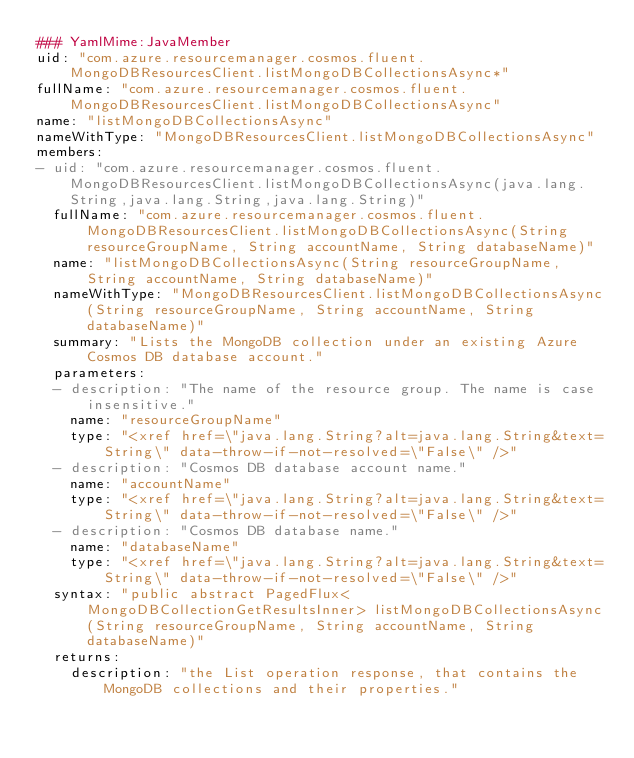Convert code to text. <code><loc_0><loc_0><loc_500><loc_500><_YAML_>### YamlMime:JavaMember
uid: "com.azure.resourcemanager.cosmos.fluent.MongoDBResourcesClient.listMongoDBCollectionsAsync*"
fullName: "com.azure.resourcemanager.cosmos.fluent.MongoDBResourcesClient.listMongoDBCollectionsAsync"
name: "listMongoDBCollectionsAsync"
nameWithType: "MongoDBResourcesClient.listMongoDBCollectionsAsync"
members:
- uid: "com.azure.resourcemanager.cosmos.fluent.MongoDBResourcesClient.listMongoDBCollectionsAsync(java.lang.String,java.lang.String,java.lang.String)"
  fullName: "com.azure.resourcemanager.cosmos.fluent.MongoDBResourcesClient.listMongoDBCollectionsAsync(String resourceGroupName, String accountName, String databaseName)"
  name: "listMongoDBCollectionsAsync(String resourceGroupName, String accountName, String databaseName)"
  nameWithType: "MongoDBResourcesClient.listMongoDBCollectionsAsync(String resourceGroupName, String accountName, String databaseName)"
  summary: "Lists the MongoDB collection under an existing Azure Cosmos DB database account."
  parameters:
  - description: "The name of the resource group. The name is case insensitive."
    name: "resourceGroupName"
    type: "<xref href=\"java.lang.String?alt=java.lang.String&text=String\" data-throw-if-not-resolved=\"False\" />"
  - description: "Cosmos DB database account name."
    name: "accountName"
    type: "<xref href=\"java.lang.String?alt=java.lang.String&text=String\" data-throw-if-not-resolved=\"False\" />"
  - description: "Cosmos DB database name."
    name: "databaseName"
    type: "<xref href=\"java.lang.String?alt=java.lang.String&text=String\" data-throw-if-not-resolved=\"False\" />"
  syntax: "public abstract PagedFlux<MongoDBCollectionGetResultsInner> listMongoDBCollectionsAsync(String resourceGroupName, String accountName, String databaseName)"
  returns:
    description: "the List operation response, that contains the MongoDB collections and their properties."</code> 